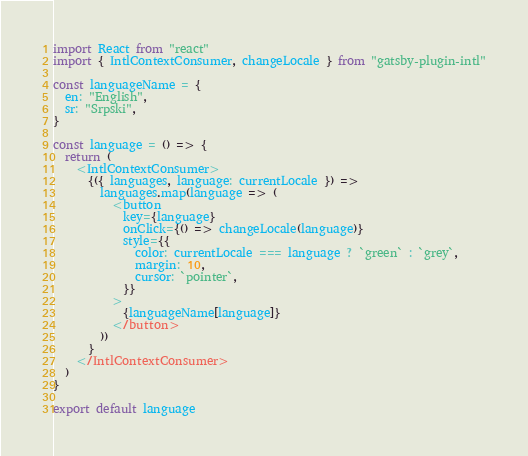<code> <loc_0><loc_0><loc_500><loc_500><_JavaScript_>import React from "react"
import { IntlContextConsumer, changeLocale } from "gatsby-plugin-intl"

const languageName = {
  en: "English",
  sr: "Srpski",
}

const language = () => {
  return (
    <IntlContextConsumer>
      {({ languages, language: currentLocale }) =>
        languages.map(language => (
          <button
            key={language}
            onClick={() => changeLocale(language)}
            style={{
              color: currentLocale === language ? `green` : `grey`,
              margin: 10,
              cursor: `pointer`,
            }}
          >
            {languageName[language]}
          </button>
        ))
      }
    </IntlContextConsumer>
  )
}

export default language
</code> 